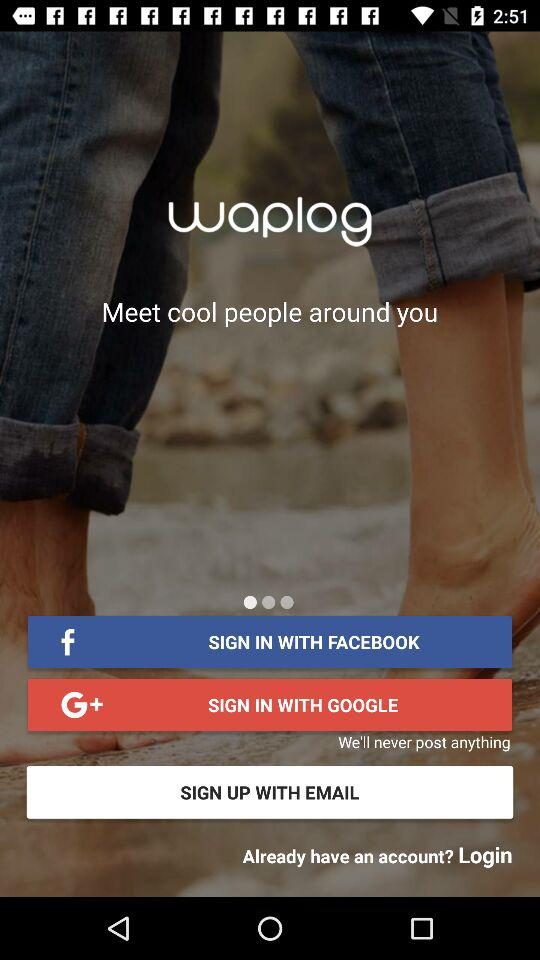What accounts can be used to sign up? Signing up can be done through "EMAIL". 